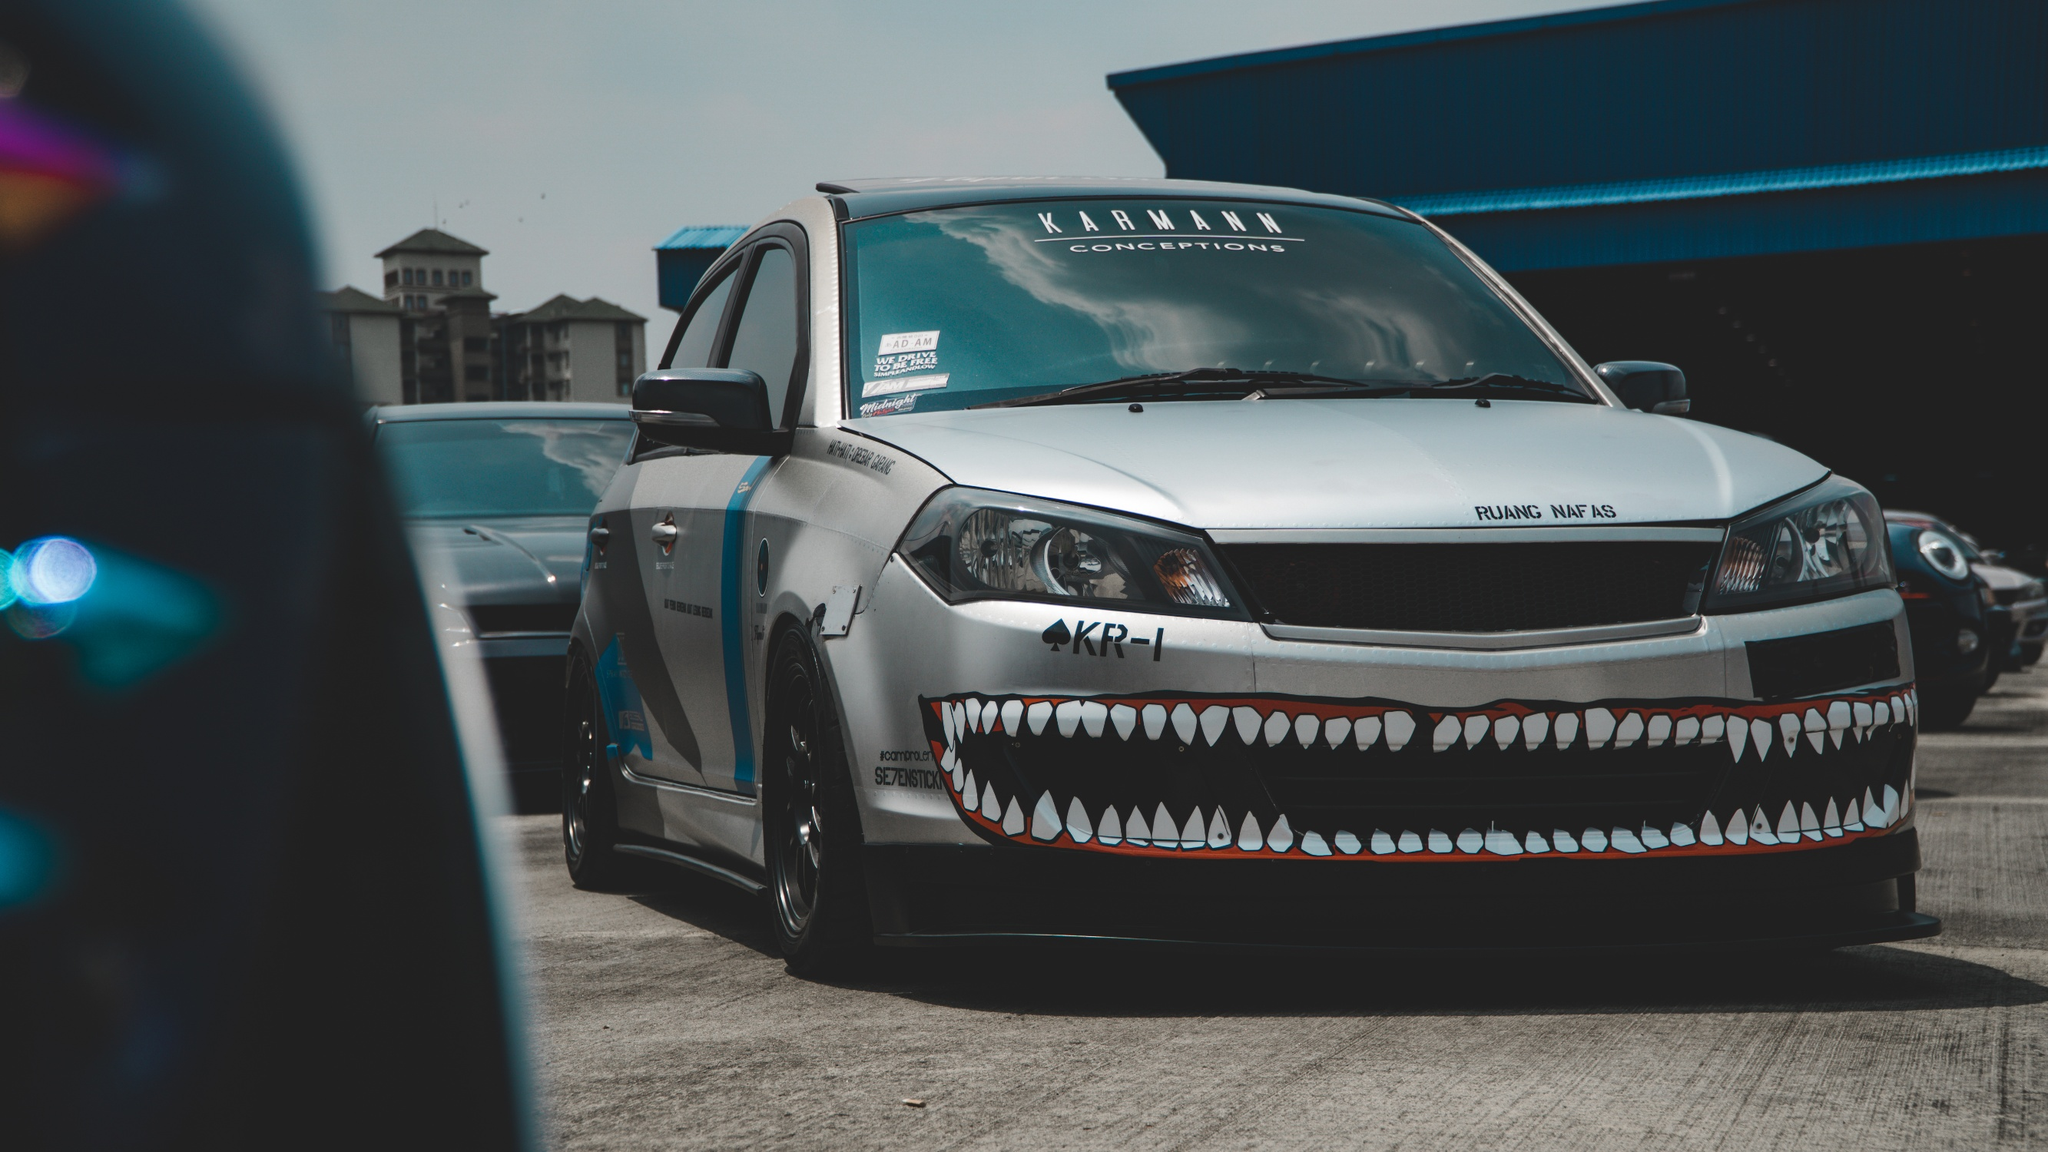If this car could talk, what would it say about its life and experiences? 'Let me tell you about the roads I've conquered and the tracks I've burned through. I'm 'The Shark', but my friends just call me 'Sharkie'. From the moment my owner laid down that first strip of paint for my teeth, I knew I was destined for greatness. We've traveled far and wide, from bustling city streets to desolate backroads, always drawing stares of awe and admiration. I've roared alongside the best of them at car shows, basking in the cameras' flashes, and I've left rivals in the dust on more than one occasion at the races. My engine is my heart, and it beats fiercely with every purr and growl. Life in the fast lane isn't just a metaphor for me; it's my reality. Parked here, I might seem at rest, but my tires itch for the next rush of adrenaline, the next challenge. Every scratch, every scuff tells a story of a wild adventure, and trust me, there are many more to come. Stay tuned, because 'Sharkie' is nowhere near the end of its journey.' When the sun dips below the horizon, the once ordinary parking lot transforms into a clandestine gathering place for supercars, each with its own story and personality. As the stars begin to twinkle, the hum of engines fills the air as sleek, powerful machines glide into their designated spots. 'The Shark' takes its place at the center, its teeth gleaming under the moonlight. It's here that these extraordinary vehicles share tales of thrilling races, daring escapes, and the distinct paths that led them to this hidden sanctuary. The cars communicate through a blend of engine roars, headlight flashes, and subtle vibrations, each conversation a symphony of power and speed. They discuss plans to outsmart traffic patrols, plot routes for the next great adventure, and share whispered secrets of hidden shortcuts and legendary drivers. As the night deepens, an aura of camaraderie envelops the lot, binding these majestic machines in a brotherhood of steel and horsepower, until the first rays of dawn signal the end of another secret rendezvous. 